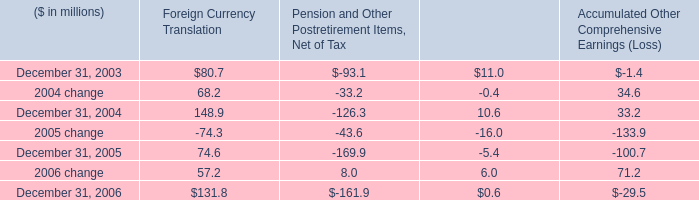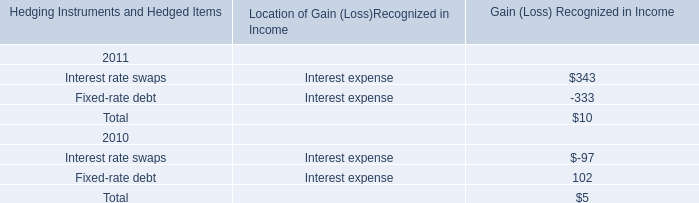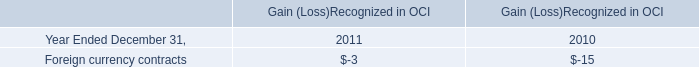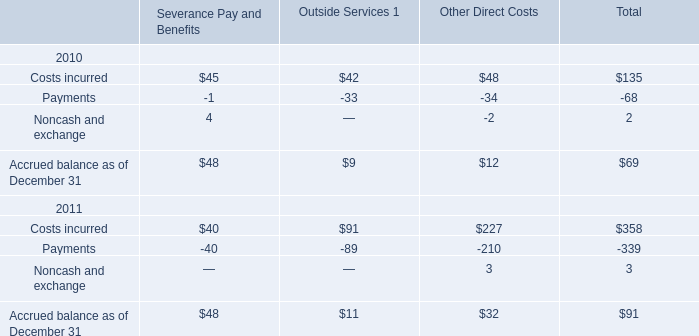What's the greatest value of Outside Services 1 in 2010? 
Answer: 42. 